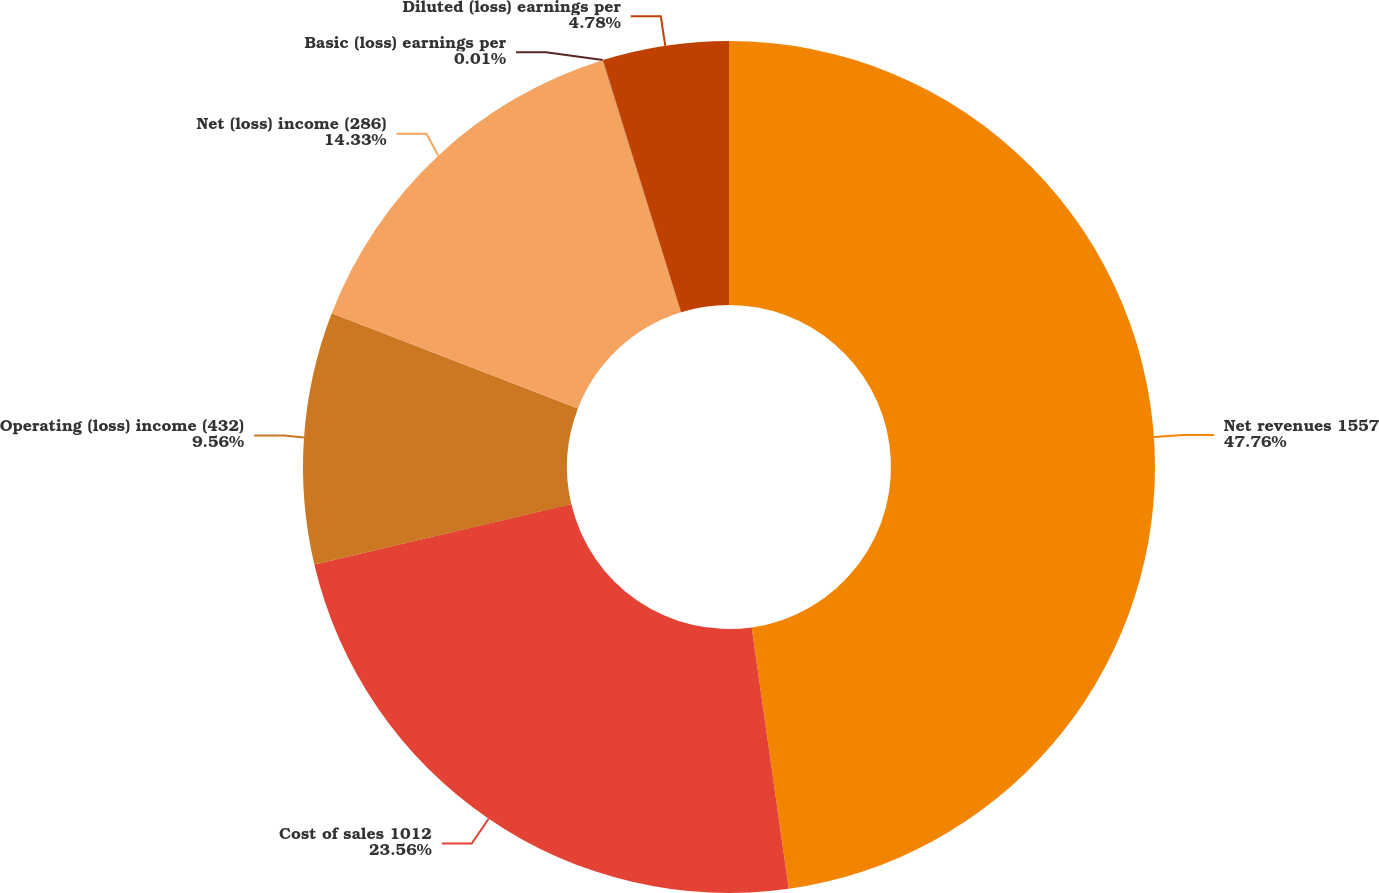Convert chart to OTSL. <chart><loc_0><loc_0><loc_500><loc_500><pie_chart><fcel>Net revenues 1557<fcel>Cost of sales 1012<fcel>Operating (loss) income (432)<fcel>Net (loss) income (286)<fcel>Basic (loss) earnings per<fcel>Diluted (loss) earnings per<nl><fcel>47.76%<fcel>23.56%<fcel>9.56%<fcel>14.33%<fcel>0.01%<fcel>4.78%<nl></chart> 